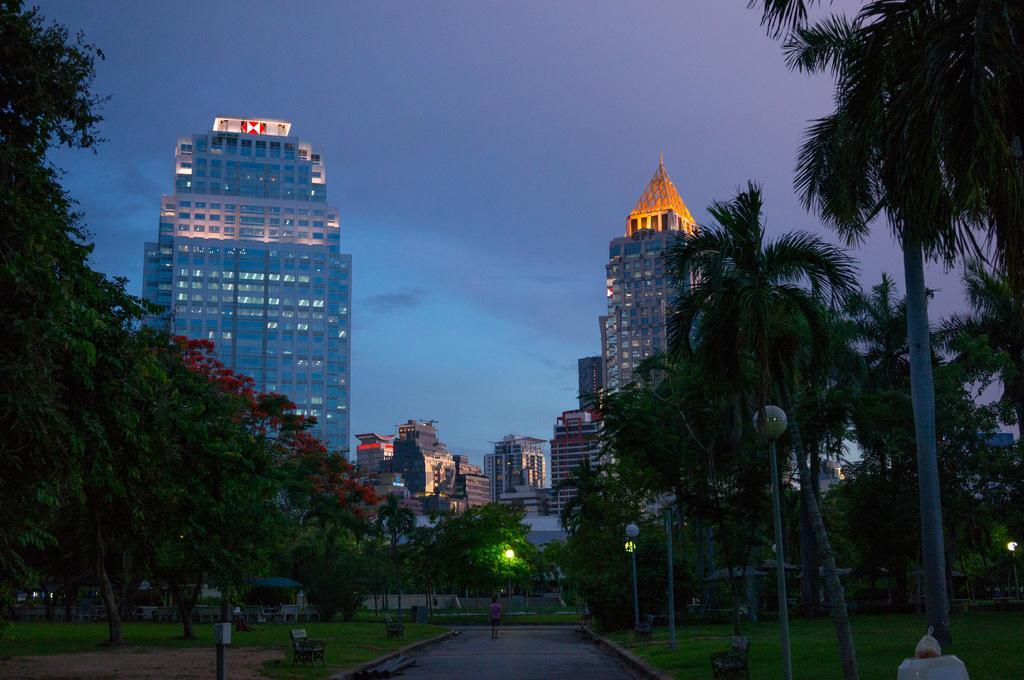Can you describe this image briefly? In this picture we can see some trees in the garden. On the right side there are some coconut trees and light poles. Behind there is a big buildings and glass windows. 